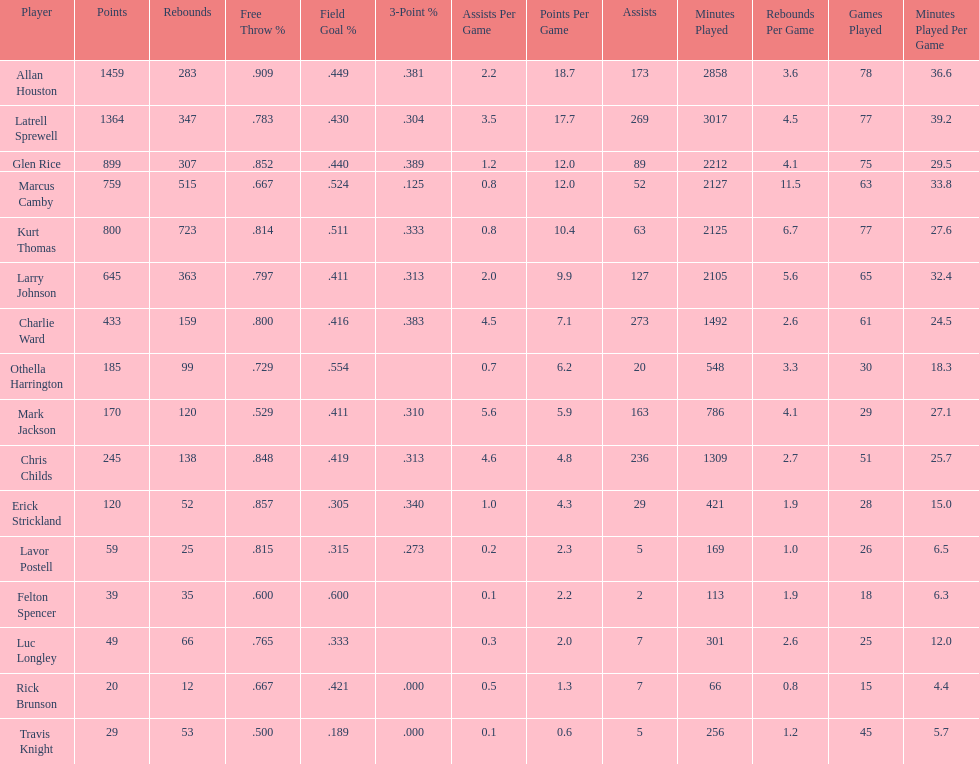How many players had a field goal percentage greater than .500? 4. 